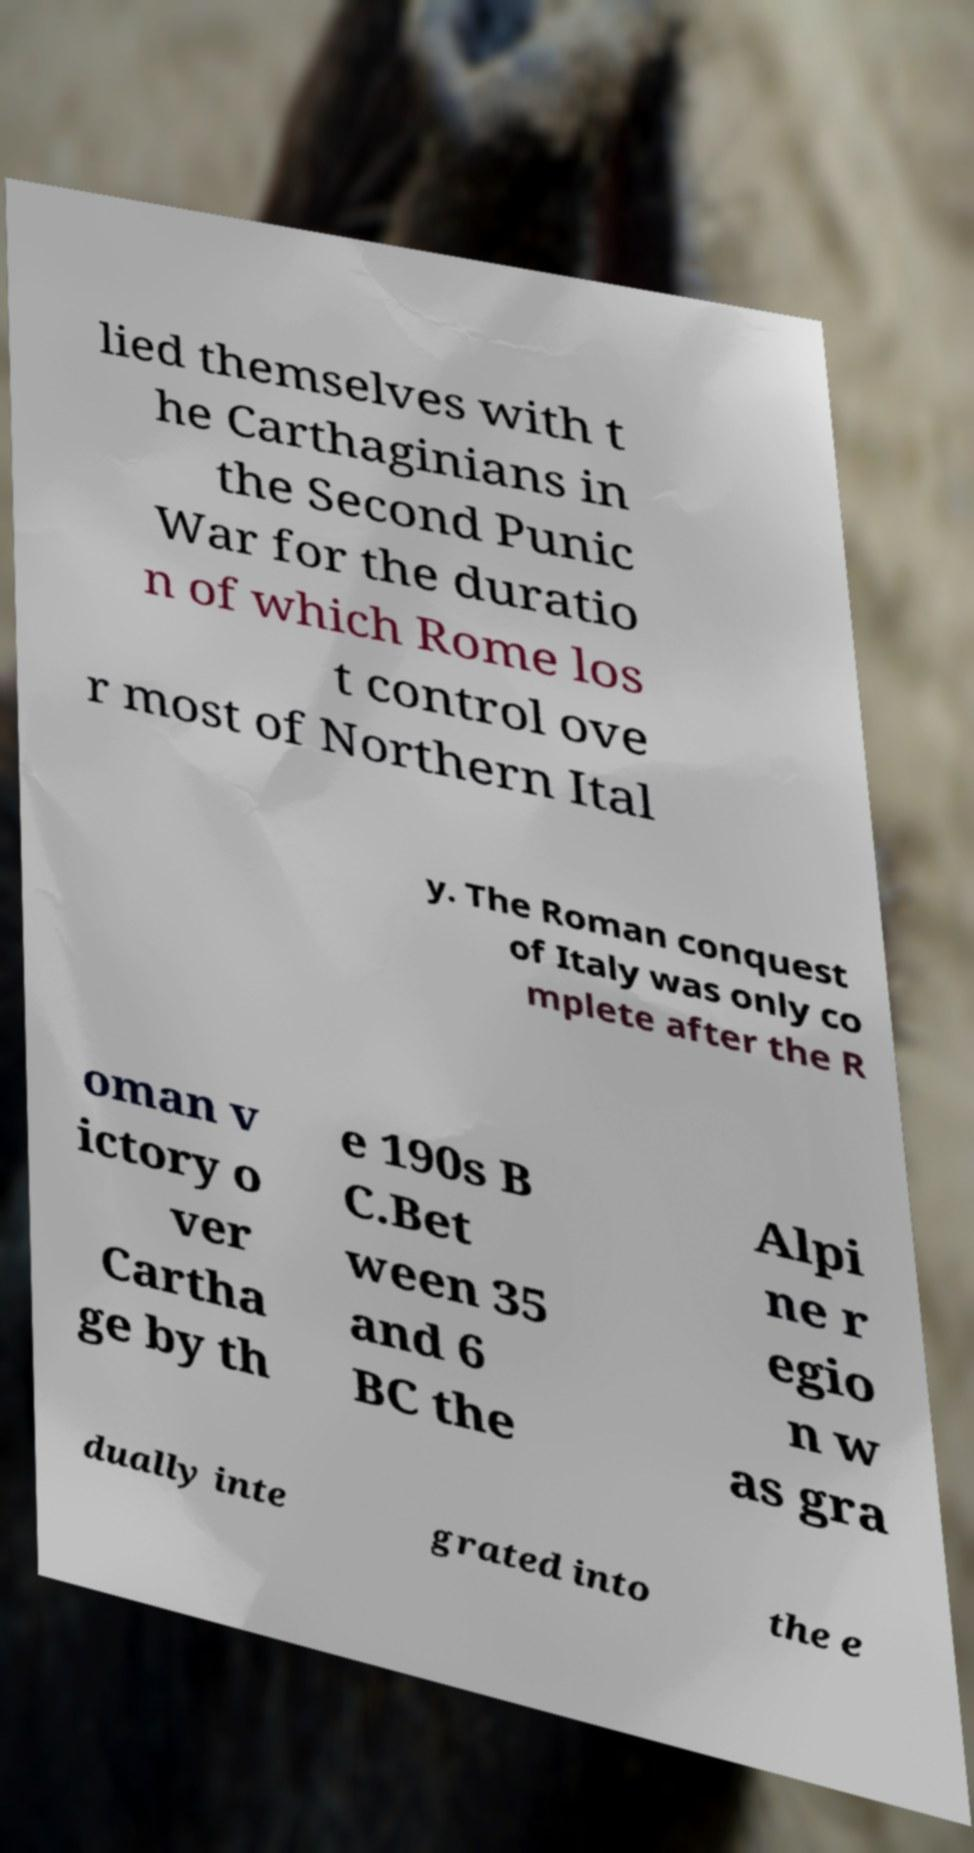I need the written content from this picture converted into text. Can you do that? lied themselves with t he Carthaginians in the Second Punic War for the duratio n of which Rome los t control ove r most of Northern Ital y. The Roman conquest of Italy was only co mplete after the R oman v ictory o ver Cartha ge by th e 190s B C.Bet ween 35 and 6 BC the Alpi ne r egio n w as gra dually inte grated into the e 